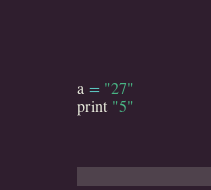Convert code to text. <code><loc_0><loc_0><loc_500><loc_500><_Python_>a = "27"
print "5"</code> 